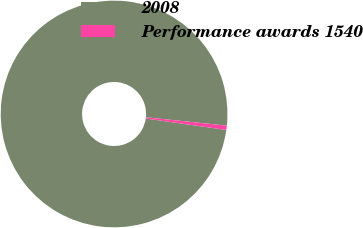<chart> <loc_0><loc_0><loc_500><loc_500><pie_chart><fcel>2008<fcel>Performance awards 1540<nl><fcel>99.39%<fcel>0.61%<nl></chart> 